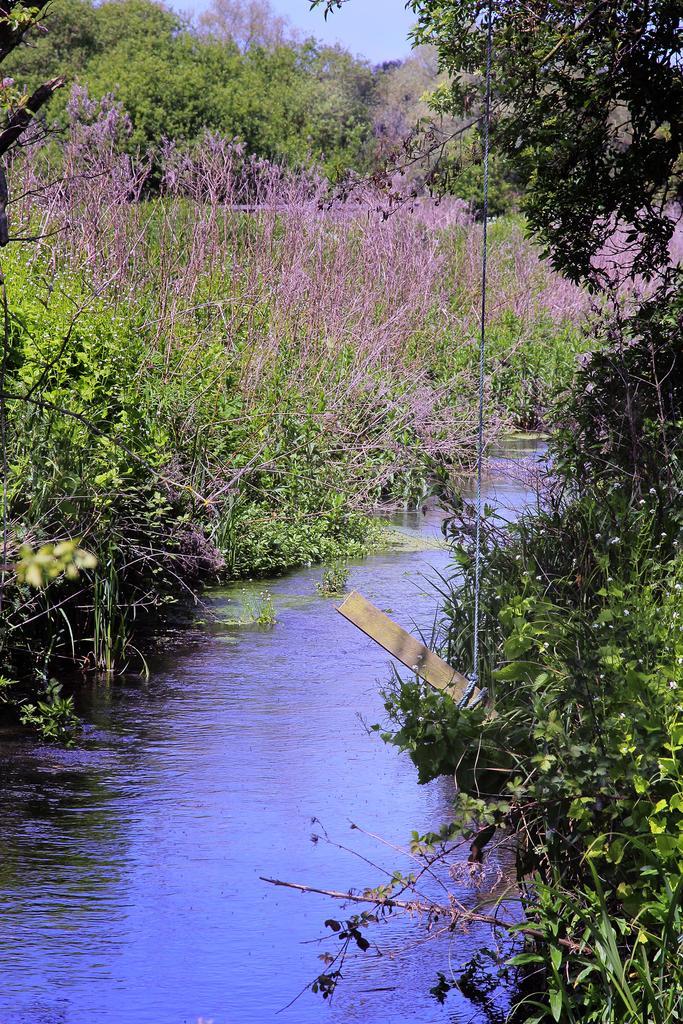Please provide a concise description of this image. In this picture we can see water, trees and a wooden stick tied with a rope and in the background we can see sky. 